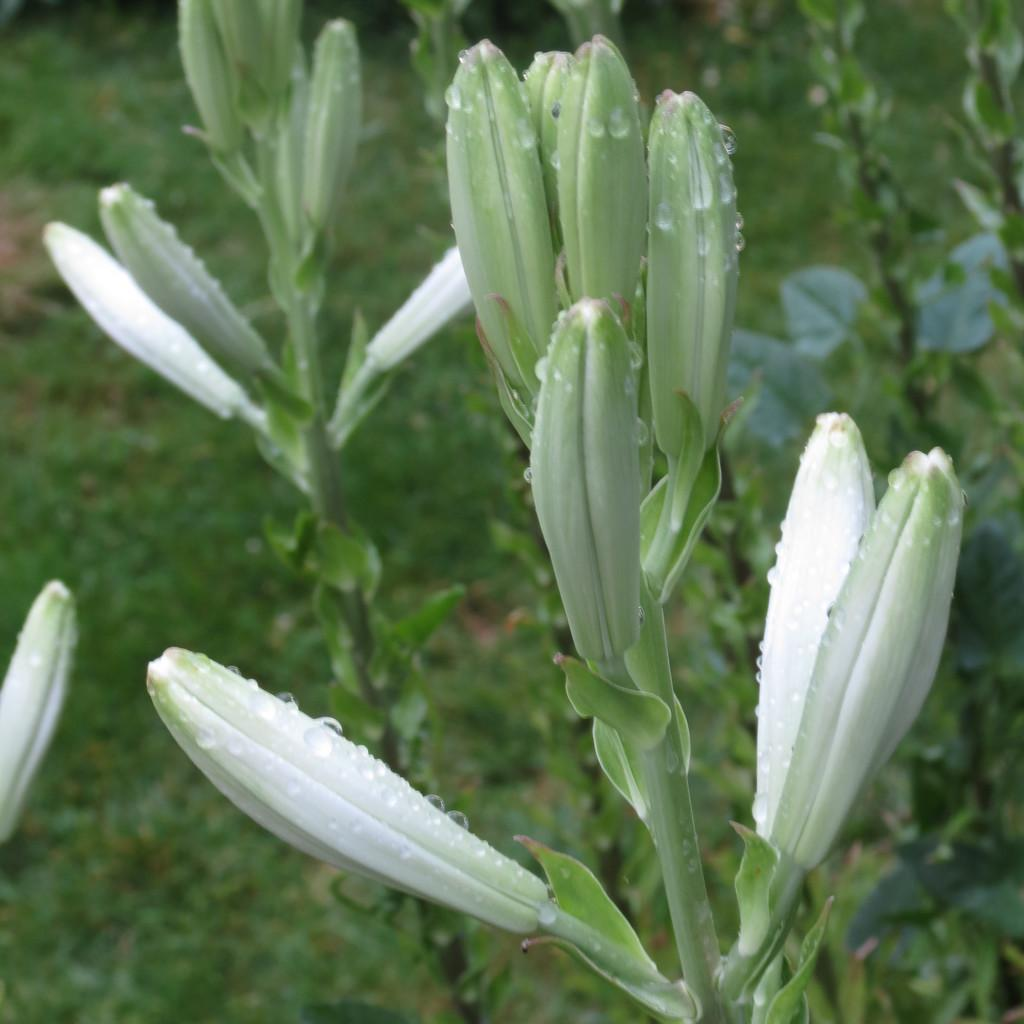What type of living organisms can be seen in the image? Plants can be seen in the image. What type of playground equipment can be seen in the image? There is no playground equipment present in the image; it only features plants. What type of bread is being used to make a sandwich in the image? There is no bread or sandwich present in the image; it only features plants. 